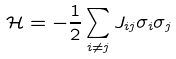<formula> <loc_0><loc_0><loc_500><loc_500>\mathcal { H } = - \frac { 1 } { 2 } \sum _ { i \neq j } J _ { i j } \sigma _ { i } \sigma _ { j }</formula> 